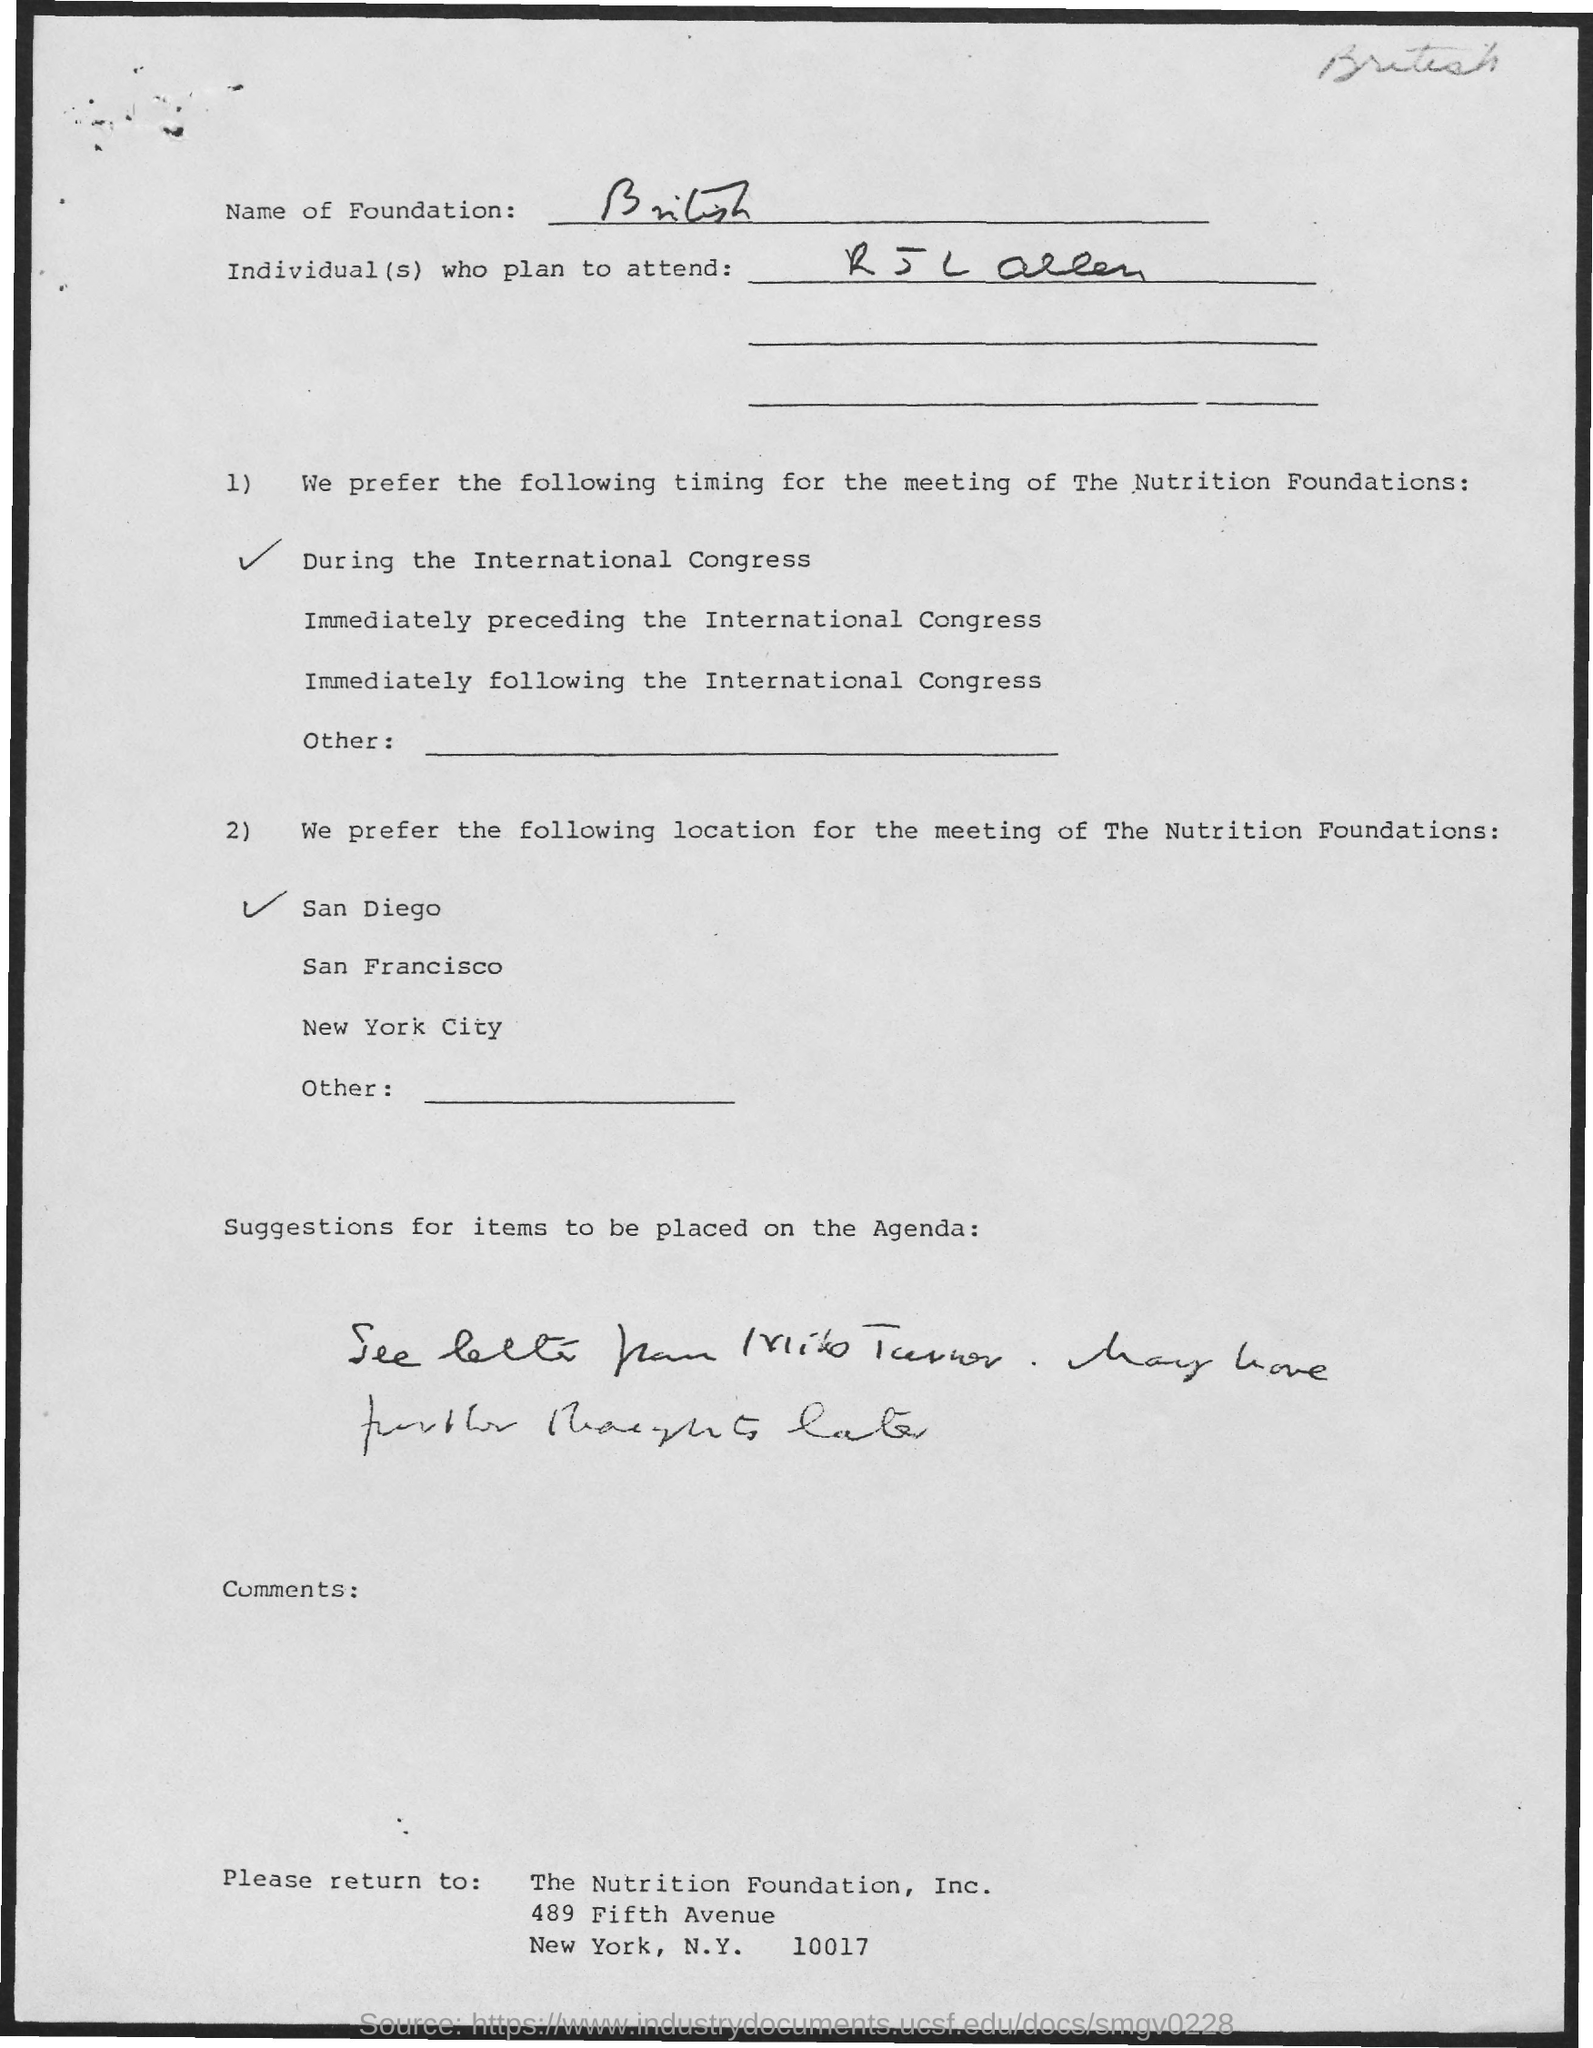What is the name of the foundation?
Provide a succinct answer. British. What is the timing for the meeting of the Nutrition Foundations?
Give a very brief answer. During the International Congress. Which is the preferred location for the meeting?
Your answer should be very brief. San Diego. What is the zipcode of the Nutrition Foundation, Inc.?
Offer a very short reply. 10017. 